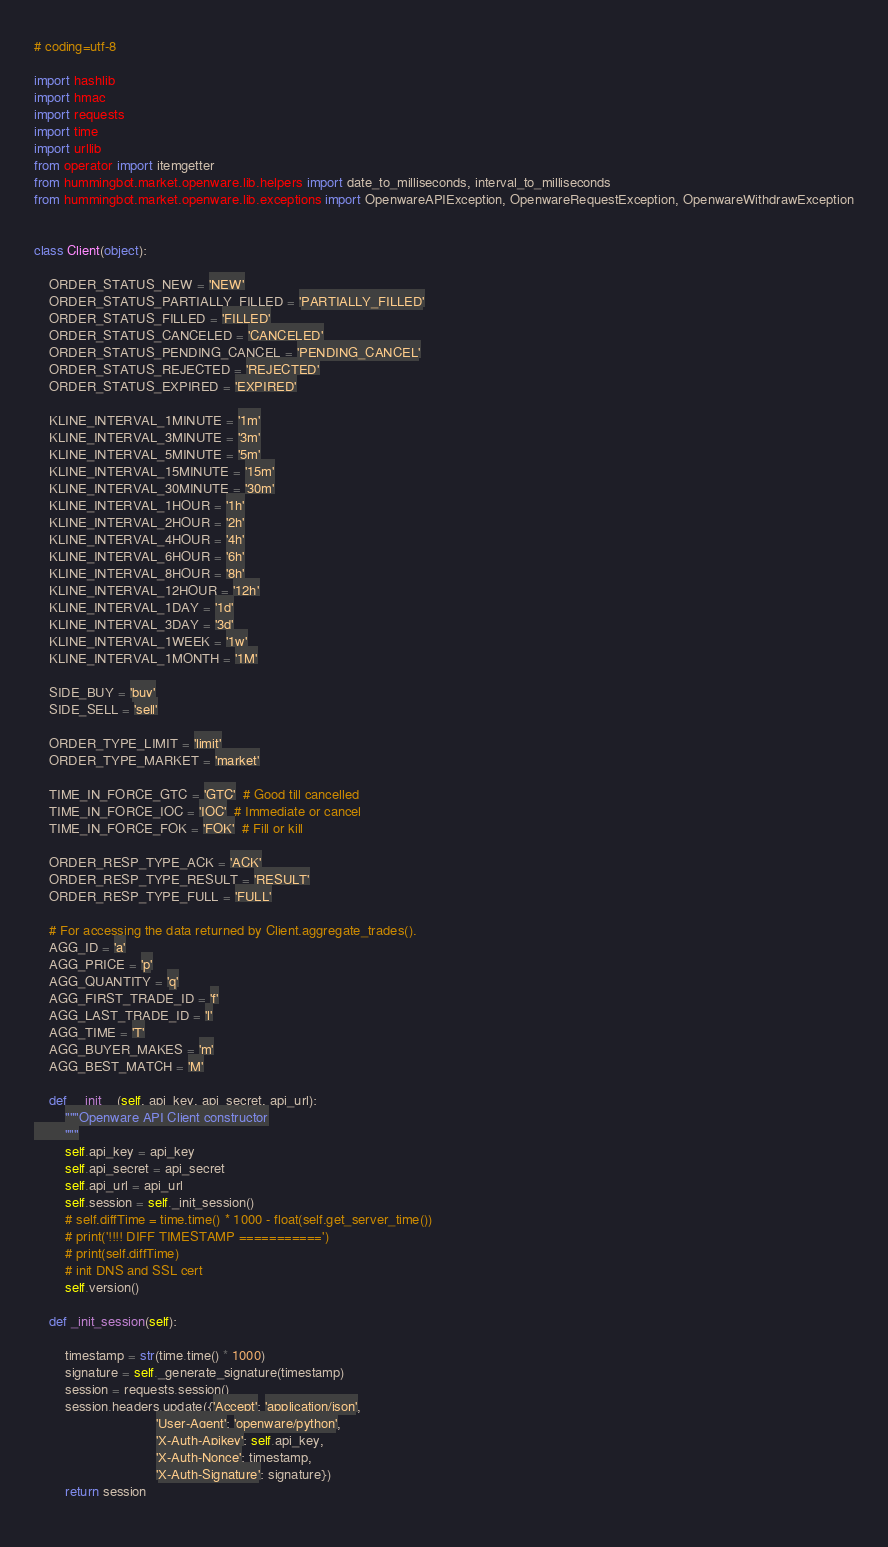Convert code to text. <code><loc_0><loc_0><loc_500><loc_500><_Python_># coding=utf-8

import hashlib
import hmac
import requests
import time
import urllib
from operator import itemgetter
from hummingbot.market.openware.lib.helpers import date_to_milliseconds, interval_to_milliseconds
from hummingbot.market.openware.lib.exceptions import OpenwareAPIException, OpenwareRequestException, OpenwareWithdrawException


class Client(object):

    ORDER_STATUS_NEW = 'NEW'
    ORDER_STATUS_PARTIALLY_FILLED = 'PARTIALLY_FILLED'
    ORDER_STATUS_FILLED = 'FILLED'
    ORDER_STATUS_CANCELED = 'CANCELED'
    ORDER_STATUS_PENDING_CANCEL = 'PENDING_CANCEL'
    ORDER_STATUS_REJECTED = 'REJECTED'
    ORDER_STATUS_EXPIRED = 'EXPIRED'

    KLINE_INTERVAL_1MINUTE = '1m'
    KLINE_INTERVAL_3MINUTE = '3m'
    KLINE_INTERVAL_5MINUTE = '5m'
    KLINE_INTERVAL_15MINUTE = '15m'
    KLINE_INTERVAL_30MINUTE = '30m'
    KLINE_INTERVAL_1HOUR = '1h'
    KLINE_INTERVAL_2HOUR = '2h'
    KLINE_INTERVAL_4HOUR = '4h'
    KLINE_INTERVAL_6HOUR = '6h'
    KLINE_INTERVAL_8HOUR = '8h'
    KLINE_INTERVAL_12HOUR = '12h'
    KLINE_INTERVAL_1DAY = '1d'
    KLINE_INTERVAL_3DAY = '3d'
    KLINE_INTERVAL_1WEEK = '1w'
    KLINE_INTERVAL_1MONTH = '1M'

    SIDE_BUY = 'buy'
    SIDE_SELL = 'sell'

    ORDER_TYPE_LIMIT = 'limit'
    ORDER_TYPE_MARKET = 'market'

    TIME_IN_FORCE_GTC = 'GTC'  # Good till cancelled
    TIME_IN_FORCE_IOC = 'IOC'  # Immediate or cancel
    TIME_IN_FORCE_FOK = 'FOK'  # Fill or kill

    ORDER_RESP_TYPE_ACK = 'ACK'
    ORDER_RESP_TYPE_RESULT = 'RESULT'
    ORDER_RESP_TYPE_FULL = 'FULL'

    # For accessing the data returned by Client.aggregate_trades().
    AGG_ID = 'a'
    AGG_PRICE = 'p'
    AGG_QUANTITY = 'q'
    AGG_FIRST_TRADE_ID = 'f'
    AGG_LAST_TRADE_ID = 'l'
    AGG_TIME = 'T'
    AGG_BUYER_MAKES = 'm'
    AGG_BEST_MATCH = 'M'

    def __init__(self, api_key, api_secret, api_url):
        """Openware API Client constructor
        """
        self.api_key = api_key
        self.api_secret = api_secret
        self.api_url = api_url
        self.session = self._init_session()
        # self.diffTime = time.time() * 1000 - float(self.get_server_time())
        # print('!!!! DIFF TIMESTAMP ===========')
        # print(self.diffTime)
        # init DNS and SSL cert
        self.version()

    def _init_session(self):

        timestamp = str(time.time() * 1000)
        signature = self._generate_signature(timestamp)
        session = requests.session()
        session.headers.update({'Accept': 'application/json',
                                'User-Agent': 'openware/python',
                                'X-Auth-Apikey': self.api_key,
                                'X-Auth-Nonce': timestamp,
                                'X-Auth-Signature': signature})
        return session
    </code> 